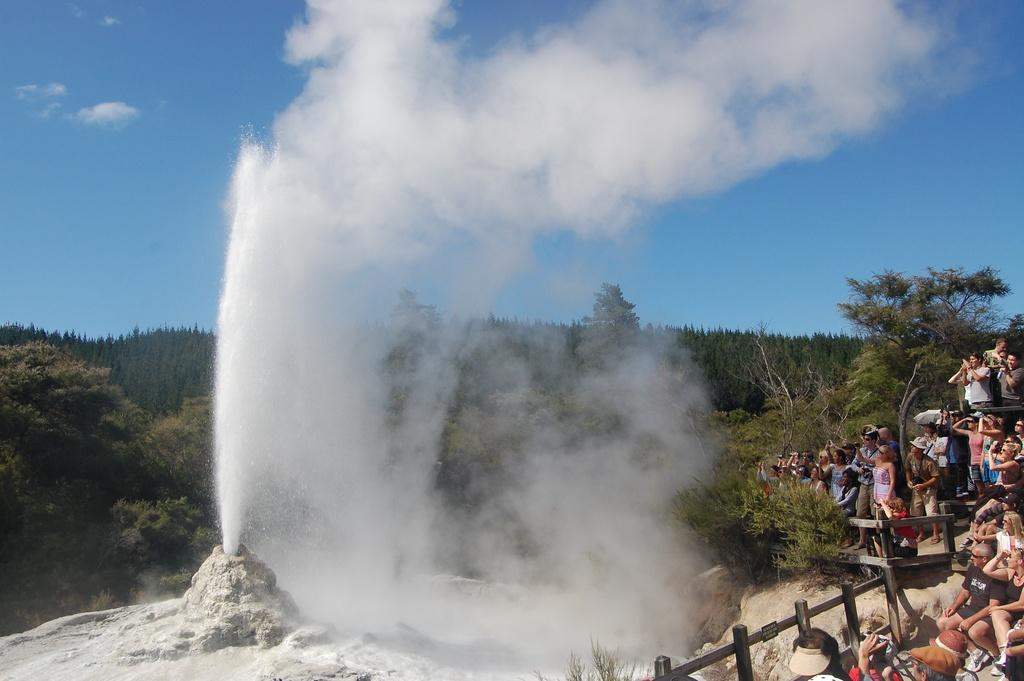What is one of the main elements visible in the image? The sky is visible in the image. What can be seen in the sky? Clouds are present in the image. What type of natural vegetation is in the image? There are trees and plants visible in the image. Is there any evidence of human activity in the image? Yes, smoke is present in the image, which may indicate human activity. What structures can be seen in the image? Fences are in the image. Are there any living beings in the image? Yes, there are people standing in the image. Can you tell me how many bees are buzzing around the window in the image? There is no window or bees present in the image. What type of porter is serving drinks to the people in the image? There is no porter or drinks being served in the image. 